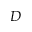<formula> <loc_0><loc_0><loc_500><loc_500>D</formula> 